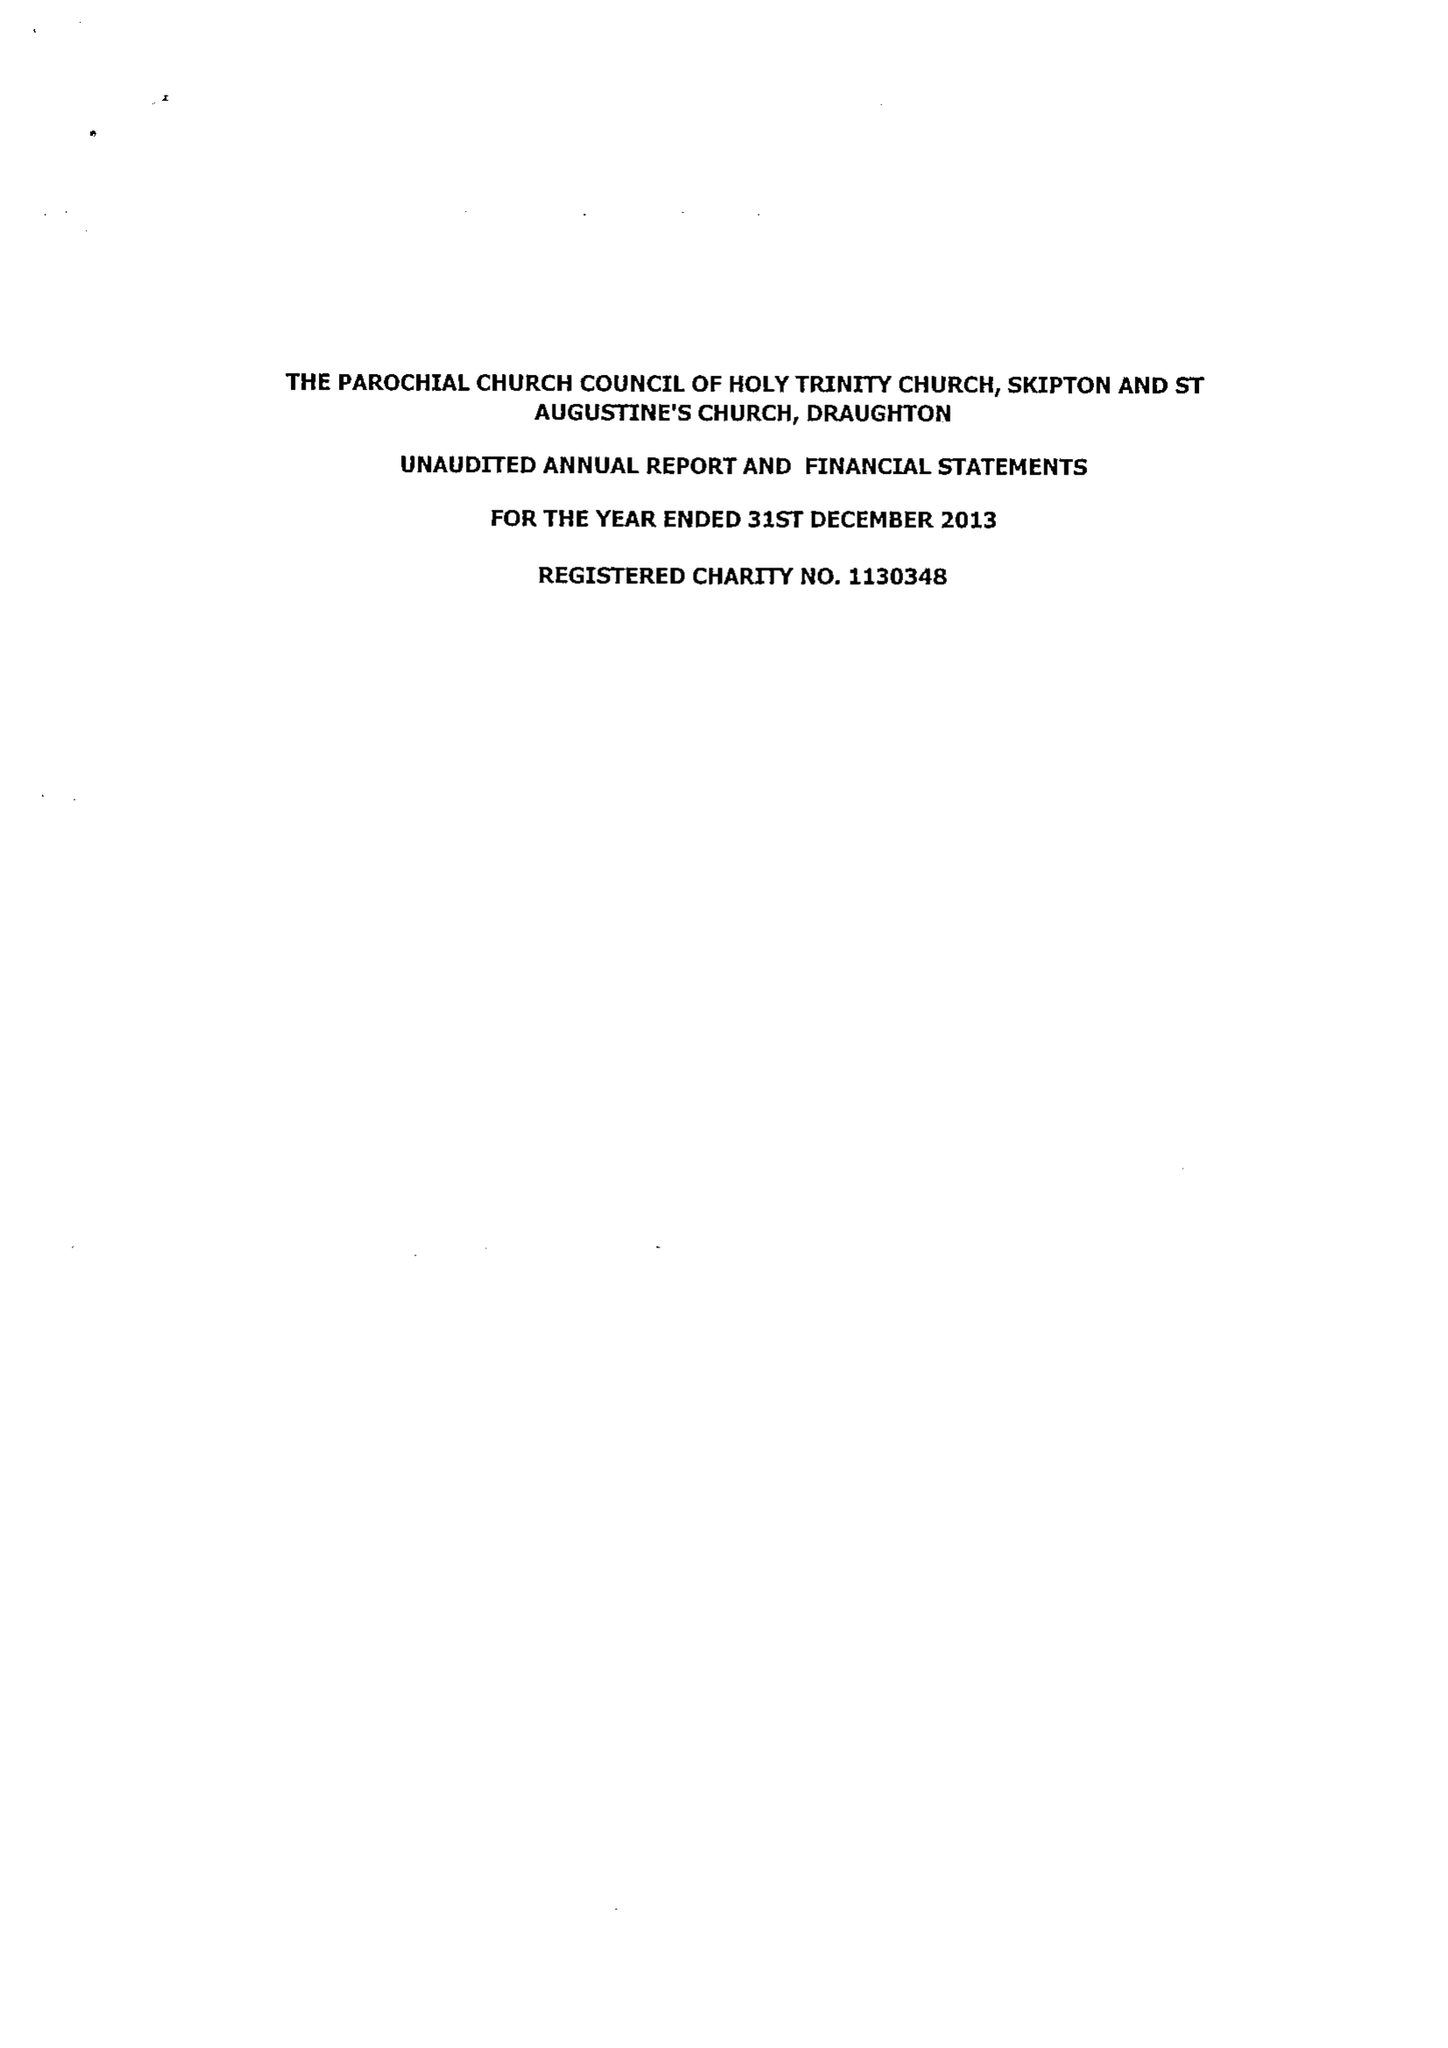What is the value for the spending_annually_in_british_pounds?
Answer the question using a single word or phrase. 163212.00 